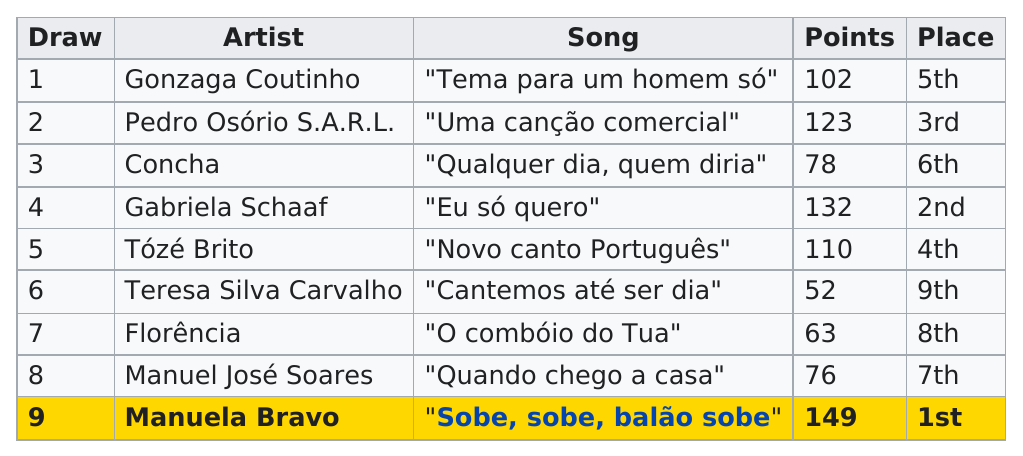List a handful of essential elements in this visual. In the Eurovision Song Contest 1979, four contestants scored over 100 points. The person who sang "eu só quero" as their song in the Eurovision Song Contest of 1979 was Gabriela Schaaf. Manuela Bravo was the last person to draw. Teresa Silva Carvalho scored the least number of points. Teresa Silva Carvalho was the artist who came in last place. 